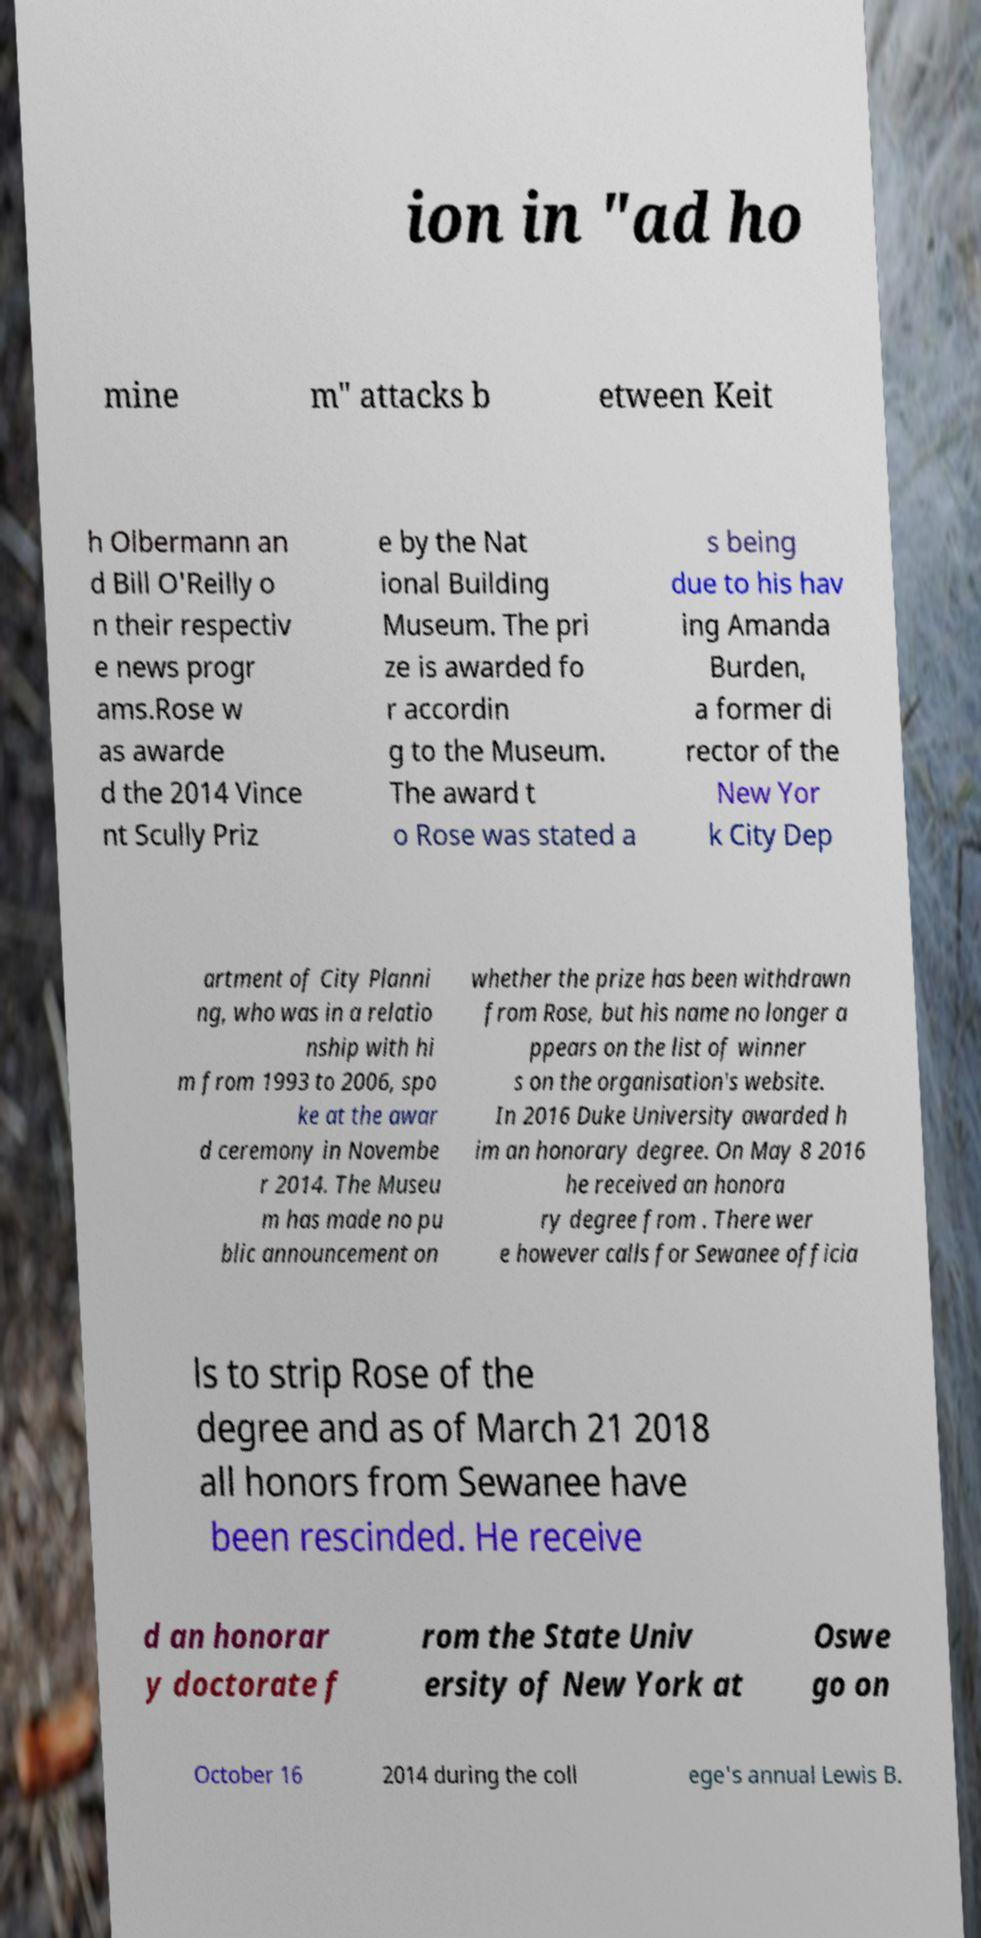Could you assist in decoding the text presented in this image and type it out clearly? ion in "ad ho mine m" attacks b etween Keit h Olbermann an d Bill O'Reilly o n their respectiv e news progr ams.Rose w as awarde d the 2014 Vince nt Scully Priz e by the Nat ional Building Museum. The pri ze is awarded fo r accordin g to the Museum. The award t o Rose was stated a s being due to his hav ing Amanda Burden, a former di rector of the New Yor k City Dep artment of City Planni ng, who was in a relatio nship with hi m from 1993 to 2006, spo ke at the awar d ceremony in Novembe r 2014. The Museu m has made no pu blic announcement on whether the prize has been withdrawn from Rose, but his name no longer a ppears on the list of winner s on the organisation's website. In 2016 Duke University awarded h im an honorary degree. On May 8 2016 he received an honora ry degree from . There wer e however calls for Sewanee officia ls to strip Rose of the degree and as of March 21 2018 all honors from Sewanee have been rescinded. He receive d an honorar y doctorate f rom the State Univ ersity of New York at Oswe go on October 16 2014 during the coll ege's annual Lewis B. 